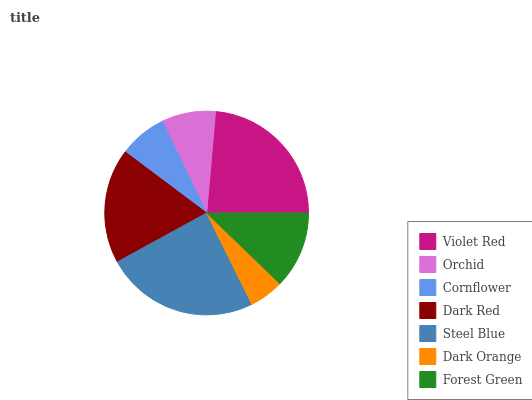Is Dark Orange the minimum?
Answer yes or no. Yes. Is Steel Blue the maximum?
Answer yes or no. Yes. Is Orchid the minimum?
Answer yes or no. No. Is Orchid the maximum?
Answer yes or no. No. Is Violet Red greater than Orchid?
Answer yes or no. Yes. Is Orchid less than Violet Red?
Answer yes or no. Yes. Is Orchid greater than Violet Red?
Answer yes or no. No. Is Violet Red less than Orchid?
Answer yes or no. No. Is Forest Green the high median?
Answer yes or no. Yes. Is Forest Green the low median?
Answer yes or no. Yes. Is Dark Orange the high median?
Answer yes or no. No. Is Orchid the low median?
Answer yes or no. No. 